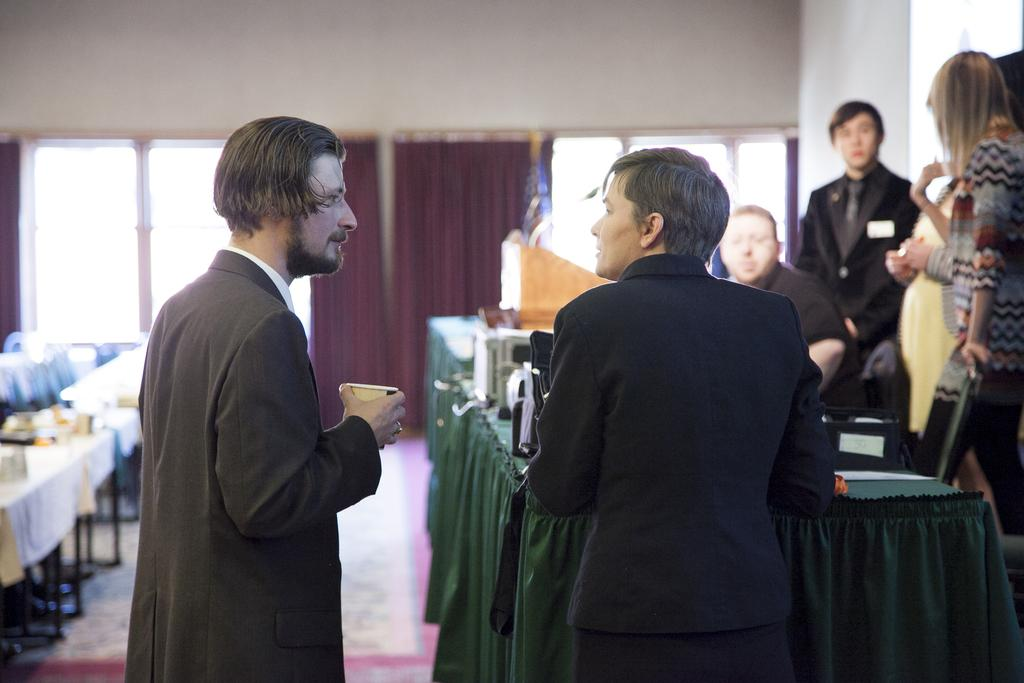How many people are in the image? There are people in the image, but the exact number is not specified. What type of furniture is present in the image? There are tables in the image. What can be seen through the windows in the image? The presence of windows suggests that there is a view outside, but the specifics are not mentioned. What type of window treatment is visible in the image? There are curtains in the image. What is on the tables in the image? There are things on the table, but the specific items are not described. What is one person holding in the image? One person is holding a cup. What type of pizzas are being served on the tables in the image? There is no mention of pizzas in the image; only tables, people, windows, curtains, and a cup are described. 